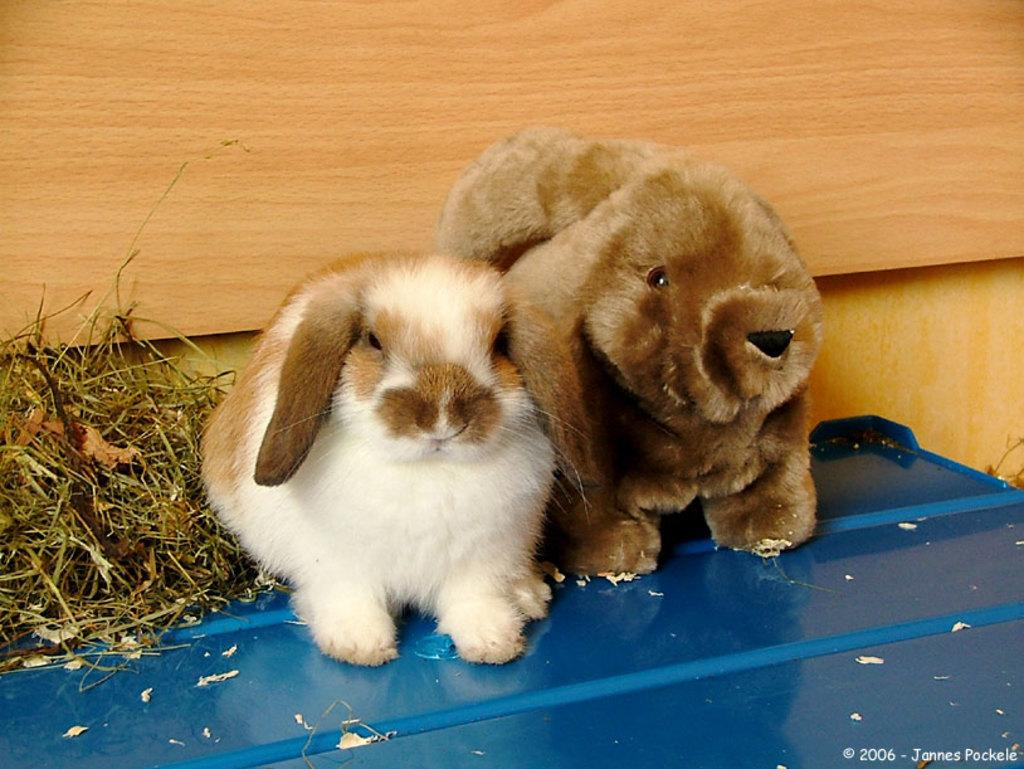What object can be seen in the image that is not a living creature? There is a toy in the image. What type of animal is present in the image? There is a rabbit in the image. What type of vegetation is near the rabbit? There is grass beside the rabbit. What type of structure can be seen in the background of the image? There is a wooden wall in the background of the image. What sound does the jellyfish make in the image? There is no jellyfish present in the image, so it cannot make any sound. 